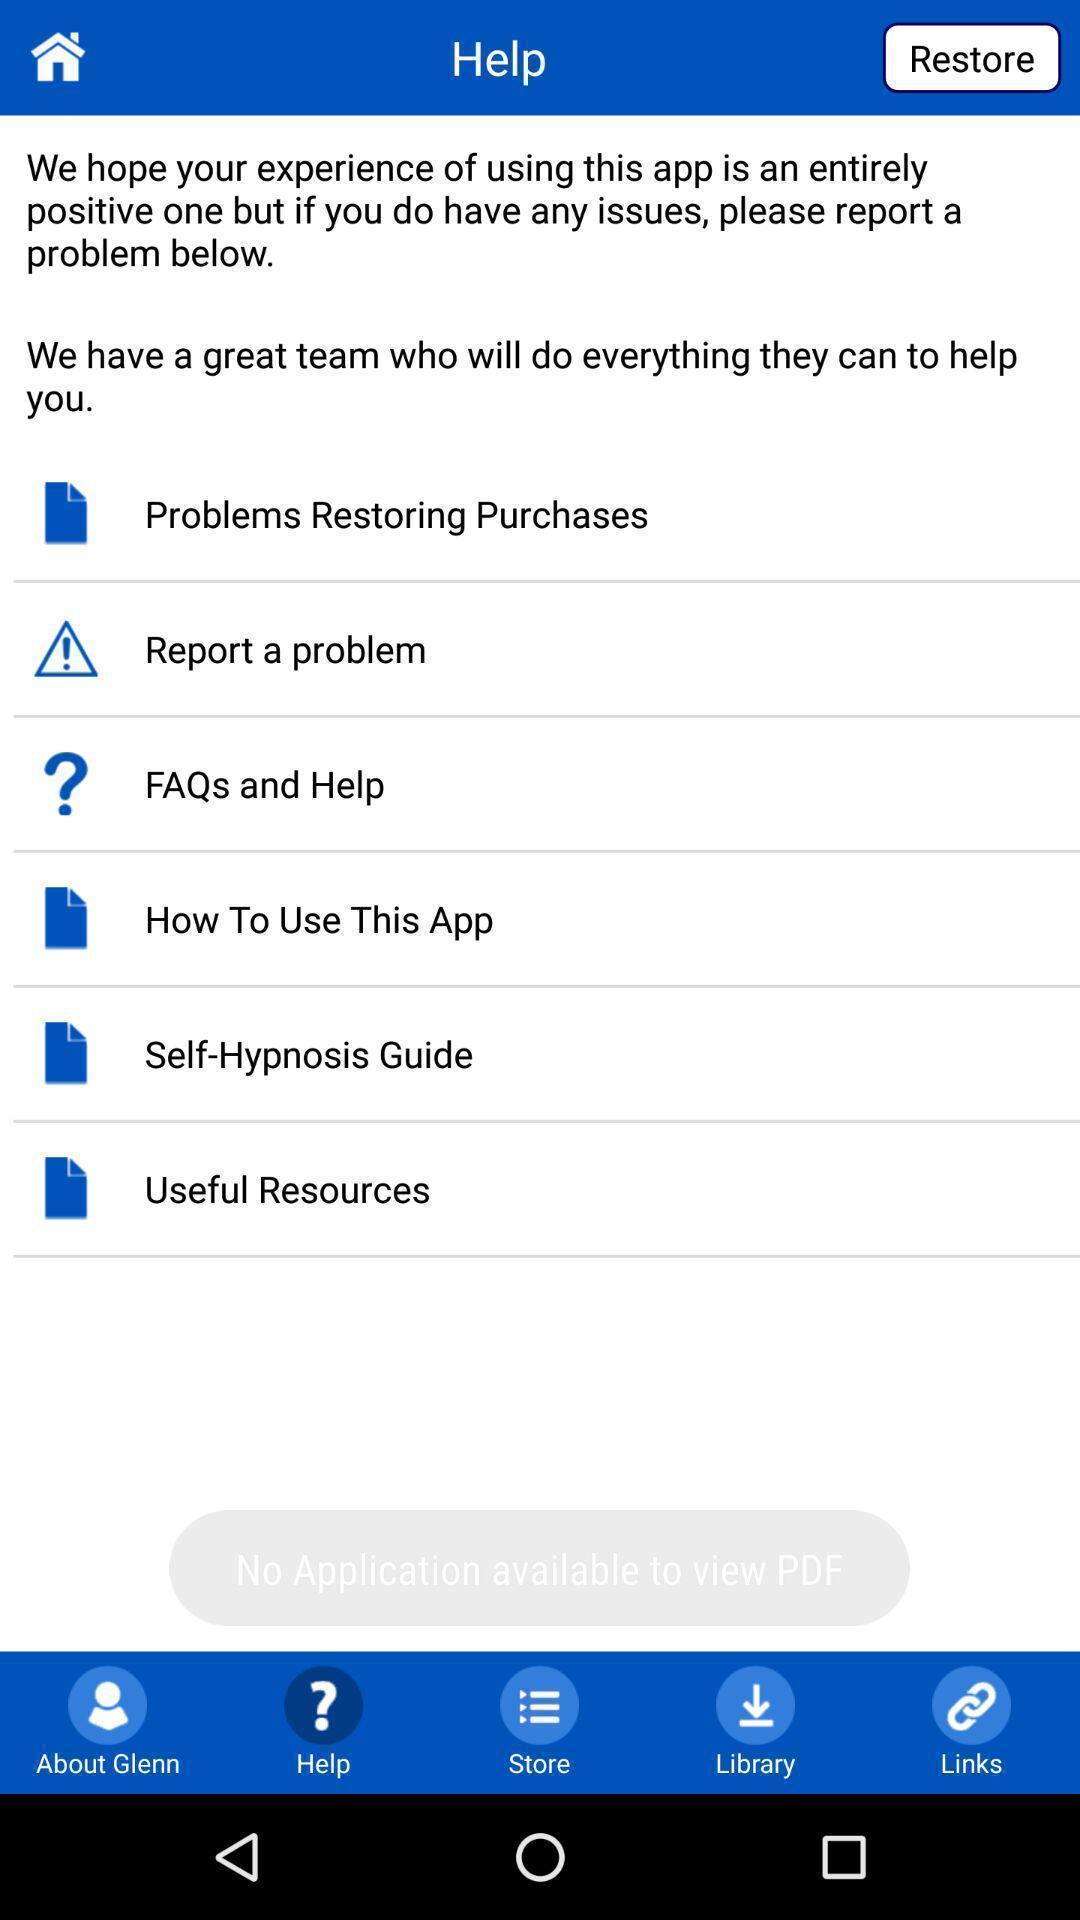Explain what's happening in this screen capture. Page displaying help options in app. 